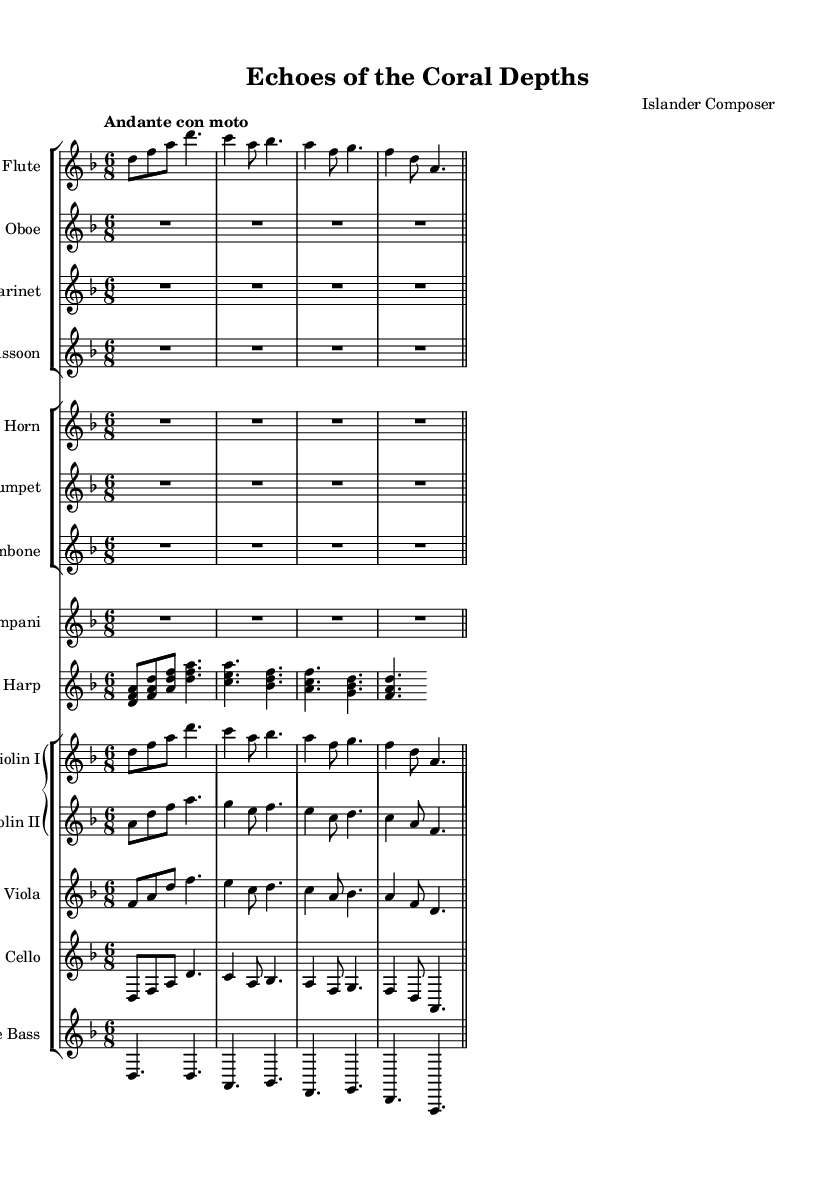What is the key signature of this music? The key signature is found at the beginning of the sheet music, indicating the number of sharps or flats. In this case, it shows two flats, which means the piece is in D minor.
Answer: D minor What is the time signature of this music? The time signature appears after the key signature at the beginning of the score. Here, it is shown as 6/8, indicating a compound time with six eighth notes in a measure.
Answer: 6/8 What is the tempo marking for this piece? The tempo marking is indicated below the clef at the start and it specifies the speed of the piece. The marking is "Andante con moto," suggesting a moderately slow tempo with some movement.
Answer: Andante con moto How many measures are present in the flute part? By counting the groups of notes separated by the bar lines in the flute part, we observe that there are four measures indicated by three bar lines.
Answer: 4 Which instruments are playing in unison in the first few measures? The first measure shows both the flute and violin I playing the same notes, indicating they are in unison. Both parts start with the note D.
Answer: Flute and Violin I What is the function of the harp in this music? The harp section in the score shows it playing arpeggiated chords, which support the harmony and fill the texture, a common role for the harp in orchestral works.
Answer: Harmonic support Which section features the lowest pitch instruments? The section includes the double bass, viola, and cello, where the double bass plays the lowest pitches, typically providing the bass foundation in the orchestration.
Answer: Double Bass 